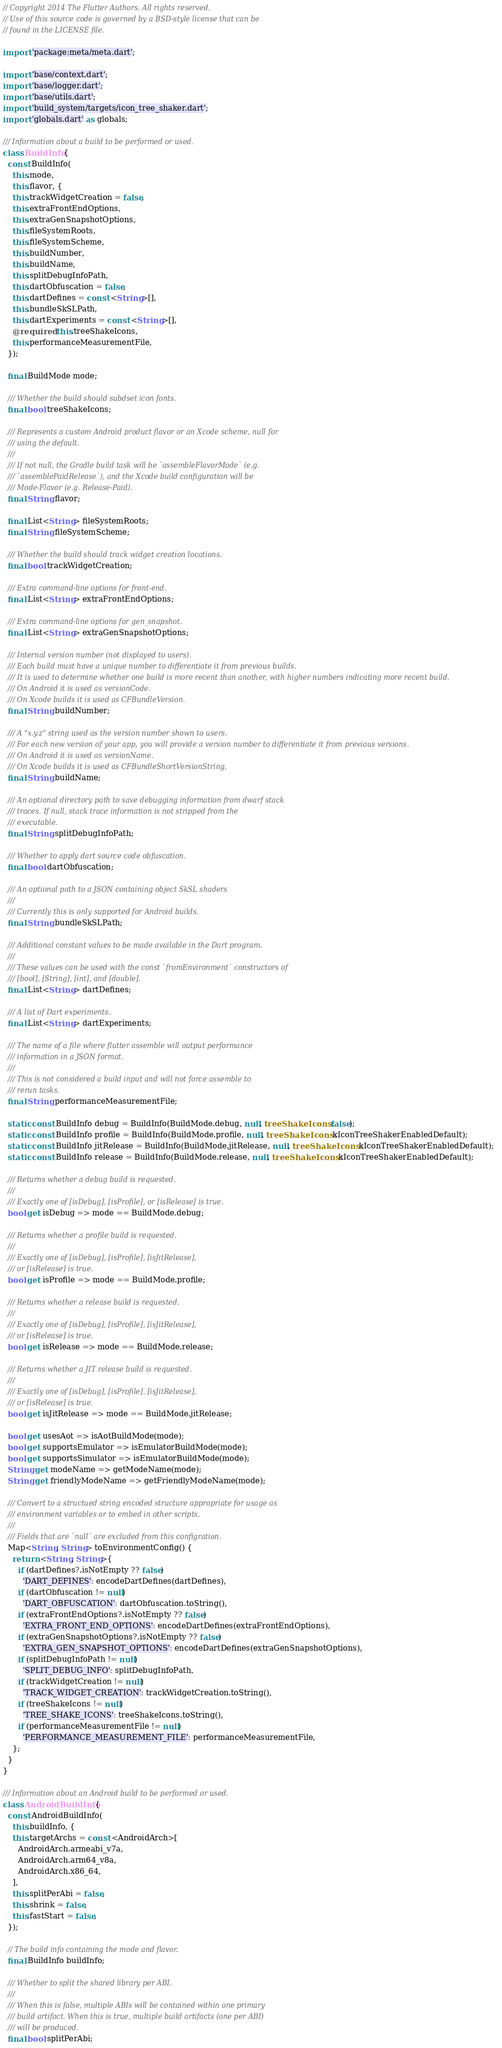<code> <loc_0><loc_0><loc_500><loc_500><_Dart_>// Copyright 2014 The Flutter Authors. All rights reserved.
// Use of this source code is governed by a BSD-style license that can be
// found in the LICENSE file.

import 'package:meta/meta.dart';

import 'base/context.dart';
import 'base/logger.dart';
import 'base/utils.dart';
import 'build_system/targets/icon_tree_shaker.dart';
import 'globals.dart' as globals;

/// Information about a build to be performed or used.
class BuildInfo {
  const BuildInfo(
    this.mode,
    this.flavor, {
    this.trackWidgetCreation = false,
    this.extraFrontEndOptions,
    this.extraGenSnapshotOptions,
    this.fileSystemRoots,
    this.fileSystemScheme,
    this.buildNumber,
    this.buildName,
    this.splitDebugInfoPath,
    this.dartObfuscation = false,
    this.dartDefines = const <String>[],
    this.bundleSkSLPath,
    this.dartExperiments = const <String>[],
    @required this.treeShakeIcons,
    this.performanceMeasurementFile,
  });

  final BuildMode mode;

  /// Whether the build should subdset icon fonts.
  final bool treeShakeIcons;

  /// Represents a custom Android product flavor or an Xcode scheme, null for
  /// using the default.
  ///
  /// If not null, the Gradle build task will be `assembleFlavorMode` (e.g.
  /// `assemblePaidRelease`), and the Xcode build configuration will be
  /// Mode-Flavor (e.g. Release-Paid).
  final String flavor;

  final List<String> fileSystemRoots;
  final String fileSystemScheme;

  /// Whether the build should track widget creation locations.
  final bool trackWidgetCreation;

  /// Extra command-line options for front-end.
  final List<String> extraFrontEndOptions;

  /// Extra command-line options for gen_snapshot.
  final List<String> extraGenSnapshotOptions;

  /// Internal version number (not displayed to users).
  /// Each build must have a unique number to differentiate it from previous builds.
  /// It is used to determine whether one build is more recent than another, with higher numbers indicating more recent build.
  /// On Android it is used as versionCode.
  /// On Xcode builds it is used as CFBundleVersion.
  final String buildNumber;

  /// A "x.y.z" string used as the version number shown to users.
  /// For each new version of your app, you will provide a version number to differentiate it from previous versions.
  /// On Android it is used as versionName.
  /// On Xcode builds it is used as CFBundleShortVersionString,
  final String buildName;

  /// An optional directory path to save debugging information from dwarf stack
  /// traces. If null, stack trace information is not stripped from the
  /// executable.
  final String splitDebugInfoPath;

  /// Whether to apply dart source code obfuscation.
  final bool dartObfuscation;

  /// An optional path to a JSON containing object SkSL shaders
  ///
  /// Currently this is only supported for Android builds.
  final String bundleSkSLPath;

  /// Additional constant values to be made available in the Dart program.
  ///
  /// These values can be used with the const `fromEnvironment` constructors of
  /// [bool], [String], [int], and [double].
  final List<String> dartDefines;

  /// A list of Dart experiments.
  final List<String> dartExperiments;

  /// The name of a file where flutter assemble will output performance
  /// information in a JSON format.
  ///
  /// This is not considered a build input and will not force assemble to
  /// rerun tasks.
  final String performanceMeasurementFile;

  static const BuildInfo debug = BuildInfo(BuildMode.debug, null, treeShakeIcons: false);
  static const BuildInfo profile = BuildInfo(BuildMode.profile, null, treeShakeIcons: kIconTreeShakerEnabledDefault);
  static const BuildInfo jitRelease = BuildInfo(BuildMode.jitRelease, null, treeShakeIcons: kIconTreeShakerEnabledDefault);
  static const BuildInfo release = BuildInfo(BuildMode.release, null, treeShakeIcons: kIconTreeShakerEnabledDefault);

  /// Returns whether a debug build is requested.
  ///
  /// Exactly one of [isDebug], [isProfile], or [isRelease] is true.
  bool get isDebug => mode == BuildMode.debug;

  /// Returns whether a profile build is requested.
  ///
  /// Exactly one of [isDebug], [isProfile], [isJitRelease],
  /// or [isRelease] is true.
  bool get isProfile => mode == BuildMode.profile;

  /// Returns whether a release build is requested.
  ///
  /// Exactly one of [isDebug], [isProfile], [isJitRelease],
  /// or [isRelease] is true.
  bool get isRelease => mode == BuildMode.release;

  /// Returns whether a JIT release build is requested.
  ///
  /// Exactly one of [isDebug], [isProfile], [isJitRelease],
  /// or [isRelease] is true.
  bool get isJitRelease => mode == BuildMode.jitRelease;

  bool get usesAot => isAotBuildMode(mode);
  bool get supportsEmulator => isEmulatorBuildMode(mode);
  bool get supportsSimulator => isEmulatorBuildMode(mode);
  String get modeName => getModeName(mode);
  String get friendlyModeName => getFriendlyModeName(mode);

  /// Convert to a structued string encoded structure appropriate for usage as
  /// environment variables or to embed in other scripts.
  ///
  /// Fields that are `null` are excluded from this configration.
  Map<String, String> toEnvironmentConfig() {
    return <String, String>{
      if (dartDefines?.isNotEmpty ?? false)
        'DART_DEFINES': encodeDartDefines(dartDefines),
      if (dartObfuscation != null)
        'DART_OBFUSCATION': dartObfuscation.toString(),
      if (extraFrontEndOptions?.isNotEmpty ?? false)
        'EXTRA_FRONT_END_OPTIONS': encodeDartDefines(extraFrontEndOptions),
      if (extraGenSnapshotOptions?.isNotEmpty ?? false)
        'EXTRA_GEN_SNAPSHOT_OPTIONS': encodeDartDefines(extraGenSnapshotOptions),
      if (splitDebugInfoPath != null)
        'SPLIT_DEBUG_INFO': splitDebugInfoPath,
      if (trackWidgetCreation != null)
        'TRACK_WIDGET_CREATION': trackWidgetCreation.toString(),
      if (treeShakeIcons != null)
        'TREE_SHAKE_ICONS': treeShakeIcons.toString(),
      if (performanceMeasurementFile != null)
        'PERFORMANCE_MEASUREMENT_FILE': performanceMeasurementFile,
    };
  }
}

/// Information about an Android build to be performed or used.
class AndroidBuildInfo {
  const AndroidBuildInfo(
    this.buildInfo, {
    this.targetArchs = const <AndroidArch>[
      AndroidArch.armeabi_v7a,
      AndroidArch.arm64_v8a,
      AndroidArch.x86_64,
    ],
    this.splitPerAbi = false,
    this.shrink = false,
    this.fastStart = false,
  });

  // The build info containing the mode and flavor.
  final BuildInfo buildInfo;

  /// Whether to split the shared library per ABI.
  ///
  /// When this is false, multiple ABIs will be contained within one primary
  /// build artifact. When this is true, multiple build artifacts (one per ABI)
  /// will be produced.
  final bool splitPerAbi;
</code> 